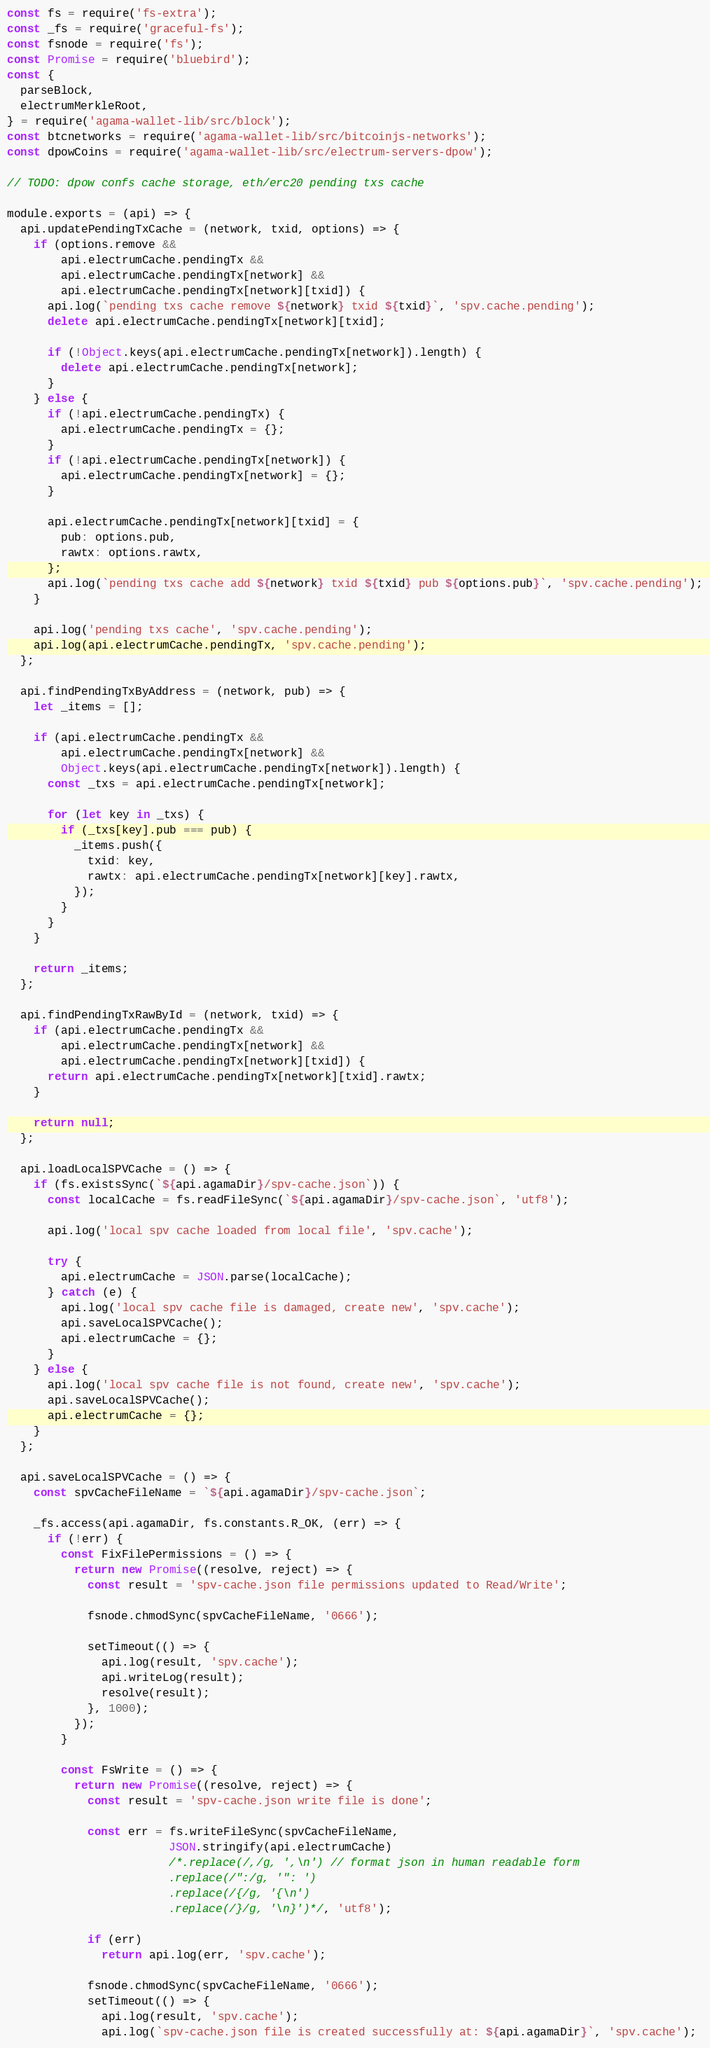<code> <loc_0><loc_0><loc_500><loc_500><_JavaScript_>const fs = require('fs-extra');
const _fs = require('graceful-fs');
const fsnode = require('fs');
const Promise = require('bluebird');
const {
  parseBlock,
  electrumMerkleRoot,
} = require('agama-wallet-lib/src/block');
const btcnetworks = require('agama-wallet-lib/src/bitcoinjs-networks');
const dpowCoins = require('agama-wallet-lib/src/electrum-servers-dpow');

// TODO: dpow confs cache storage, eth/erc20 pending txs cache 

module.exports = (api) => {
  api.updatePendingTxCache = (network, txid, options) => {
    if (options.remove &&
        api.electrumCache.pendingTx &&
        api.electrumCache.pendingTx[network] &&
        api.electrumCache.pendingTx[network][txid]) {
      api.log(`pending txs cache remove ${network} txid ${txid}`, 'spv.cache.pending');
      delete api.electrumCache.pendingTx[network][txid];

      if (!Object.keys(api.electrumCache.pendingTx[network]).length) {
        delete api.electrumCache.pendingTx[network];
      }
    } else {
      if (!api.electrumCache.pendingTx) {
        api.electrumCache.pendingTx = {};
      }
      if (!api.electrumCache.pendingTx[network]) {
        api.electrumCache.pendingTx[network] = {};
      }

      api.electrumCache.pendingTx[network][txid] = {
        pub: options.pub,
        rawtx: options.rawtx,
      };
      api.log(`pending txs cache add ${network} txid ${txid} pub ${options.pub}`, 'spv.cache.pending');
    }

    api.log('pending txs cache', 'spv.cache.pending');
    api.log(api.electrumCache.pendingTx, 'spv.cache.pending');
  };

  api.findPendingTxByAddress = (network, pub) => {
    let _items = [];

    if (api.electrumCache.pendingTx &&
        api.electrumCache.pendingTx[network] &&
        Object.keys(api.electrumCache.pendingTx[network]).length) {
      const _txs = api.electrumCache.pendingTx[network];
      
      for (let key in _txs) {
        if (_txs[key].pub === pub) {
          _items.push({
            txid: key,
            rawtx: api.electrumCache.pendingTx[network][key].rawtx, 
          });
        }
      }
    }

    return _items;
  };

  api.findPendingTxRawById = (network, txid) => {
    if (api.electrumCache.pendingTx &&
        api.electrumCache.pendingTx[network] &&
        api.electrumCache.pendingTx[network][txid]) {
      return api.electrumCache.pendingTx[network][txid].rawtx;
    }

    return null;
  };

  api.loadLocalSPVCache = () => {
    if (fs.existsSync(`${api.agamaDir}/spv-cache.json`)) {
      const localCache = fs.readFileSync(`${api.agamaDir}/spv-cache.json`, 'utf8');

      api.log('local spv cache loaded from local file', 'spv.cache');

      try {
        api.electrumCache = JSON.parse(localCache);
      } catch (e) {
        api.log('local spv cache file is damaged, create new', 'spv.cache');
        api.saveLocalSPVCache();
        api.electrumCache = {};
      }
    } else {
      api.log('local spv cache file is not found, create new', 'spv.cache');
      api.saveLocalSPVCache();
      api.electrumCache = {};
    }
  };

  api.saveLocalSPVCache = () => {
    const spvCacheFileName = `${api.agamaDir}/spv-cache.json`;

    _fs.access(api.agamaDir, fs.constants.R_OK, (err) => {
      if (!err) {
        const FixFilePermissions = () => {
          return new Promise((resolve, reject) => {
            const result = 'spv-cache.json file permissions updated to Read/Write';

            fsnode.chmodSync(spvCacheFileName, '0666');

            setTimeout(() => {
              api.log(result, 'spv.cache');
              api.writeLog(result);
              resolve(result);
            }, 1000);
          });
        }

        const FsWrite = () => {
          return new Promise((resolve, reject) => {
            const result = 'spv-cache.json write file is done';

            const err = fs.writeFileSync(spvCacheFileName,
                        JSON.stringify(api.electrumCache)
                        /*.replace(/,/g, ',\n') // format json in human readable form
                        .replace(/":/g, '": ')
                        .replace(/{/g, '{\n')
                        .replace(/}/g, '\n}')*/, 'utf8');

            if (err)
              return api.log(err, 'spv.cache');

            fsnode.chmodSync(spvCacheFileName, '0666');
            setTimeout(() => {
              api.log(result, 'spv.cache');
              api.log(`spv-cache.json file is created successfully at: ${api.agamaDir}`, 'spv.cache');</code> 